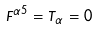<formula> <loc_0><loc_0><loc_500><loc_500>F ^ { \alpha 5 } = T _ { \alpha } = 0</formula> 